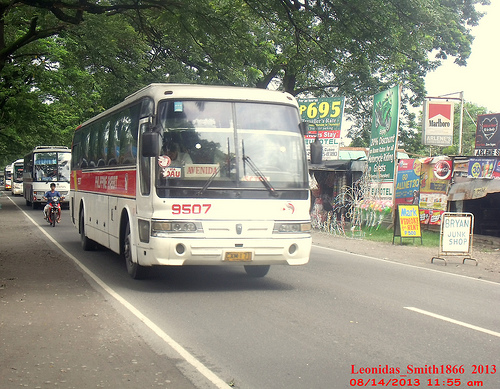Describe the scene depicted in this image. The image shows a bustling roadside scene with multiple buses moving along the road, trees overhead, and various signs and advertisements lining the side of the street. What can you observe about the buses in this image? In the image, there are several white buses with red details, seemingly part of a bus line. Each bus has a unique identifying number and some are labeled with visible route information. Picture a scenario where all the buses are converted into futuristic flying buses. Describe the changes in the scene. If the buses were converted into futuristic flying vehicles, the image would transform drastically. The buses would hover above the ground on anti-gravity engines with neon lights marking their pathways. The road might be replaced with an energy field guiding the buses. Trees and road signs would be illuminated by the buses' glow, giving the entire scene a sci-fi ambiance. Imagine this image as part of a movie scene. What would be happening right at this moment? In a movie scene, this image could depict a bustling morning in a small town. The buses might be filled with commuters heading to work or students going to school. The man on the motorcycle could be making a quick delivery while dodging between the buses. Just then, a major character might receive an urgent phone call, setting off a series of thrilling events that follow. 